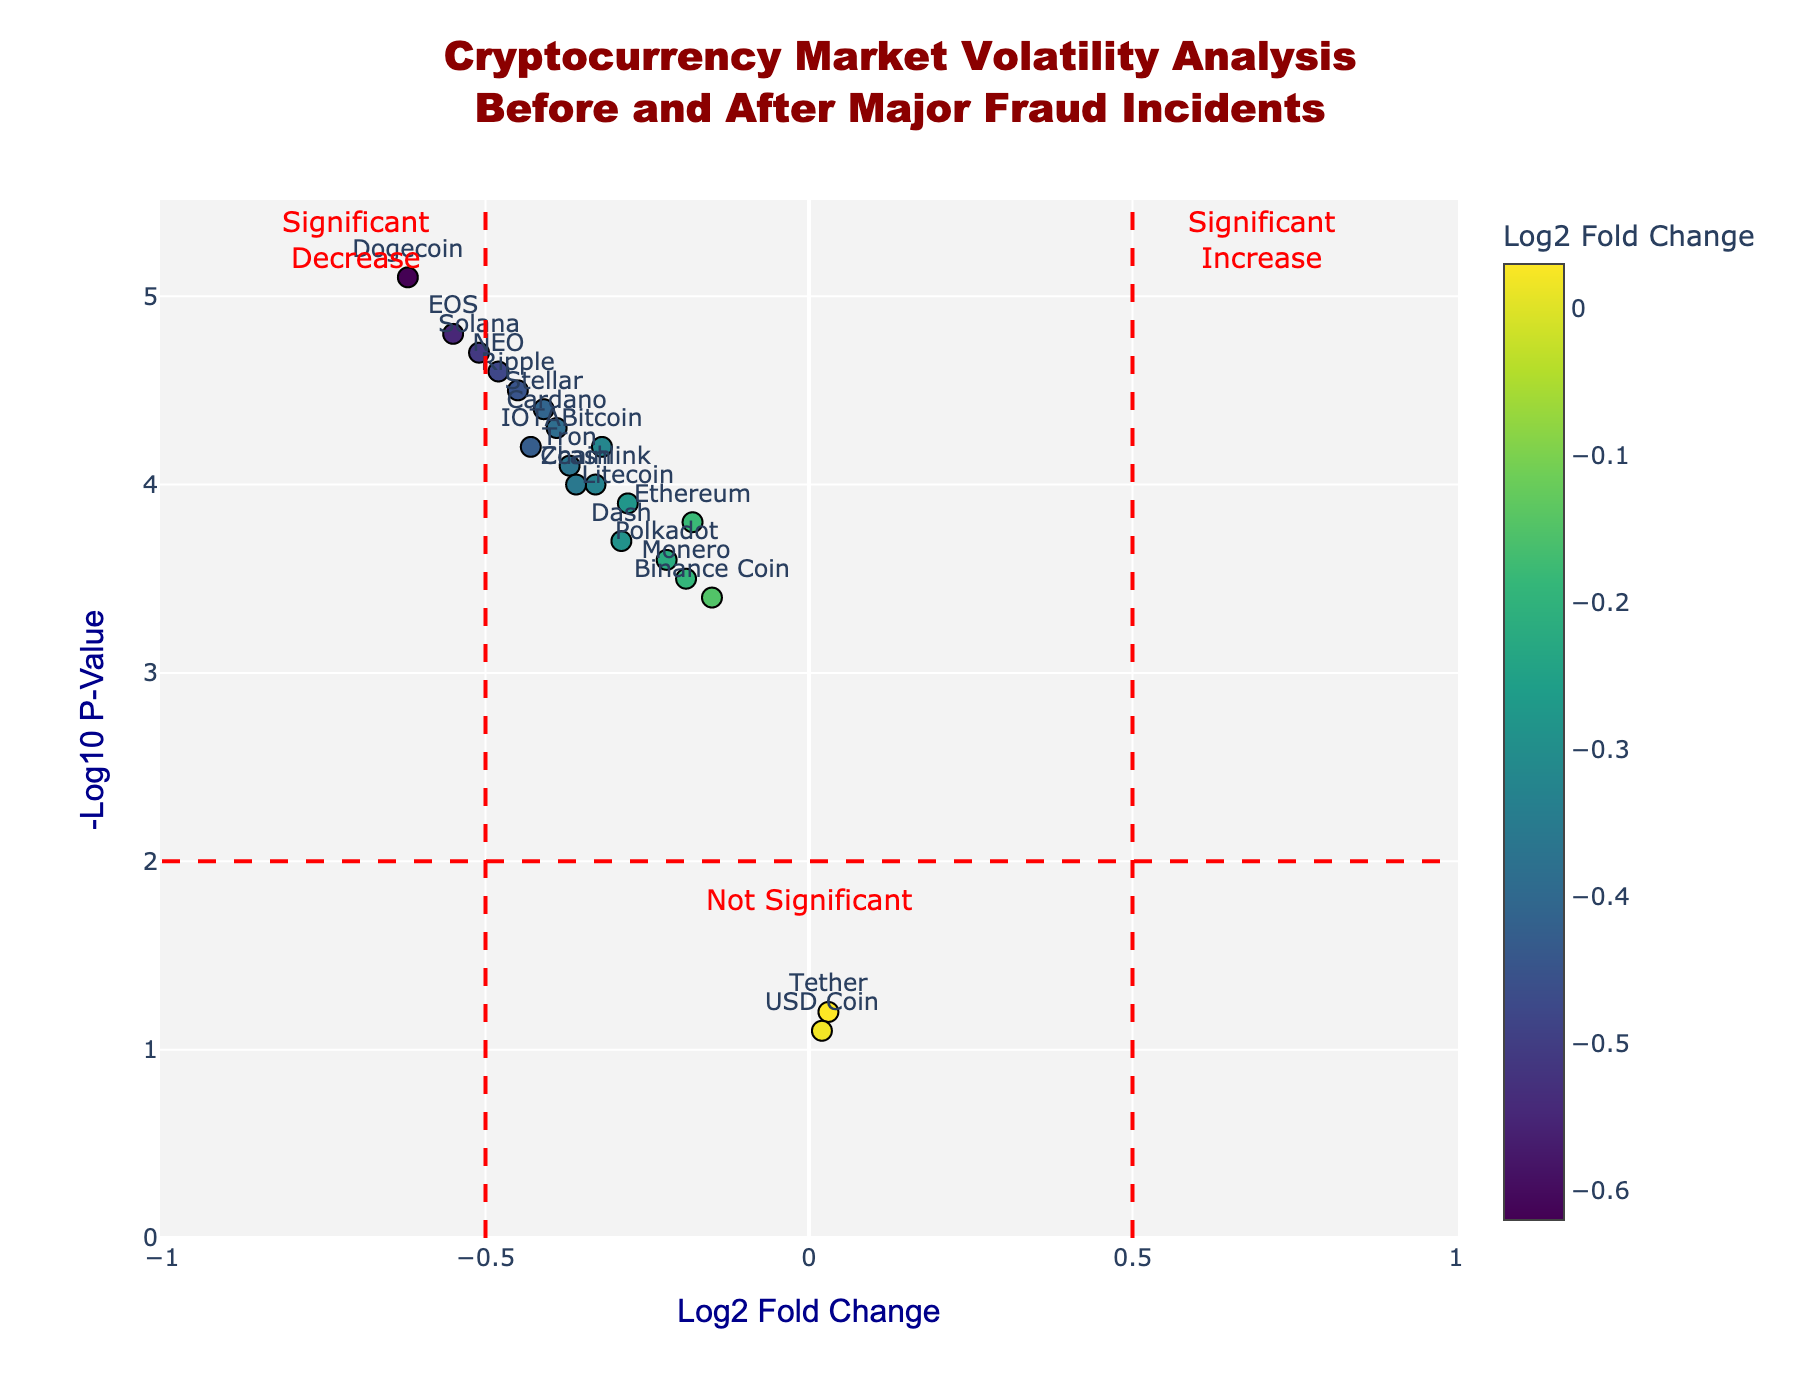What's the title of the figure? The title of the figure is prominently displayed at the top in bold font.
Answer: Cryptocurrency Market Volatility Analysis Before and After Major Fraud Incidents What do the x-axis and y-axis represent? The x-axis represents the Log2 Fold Change, and the y-axis represents the Negative Log10 P-Value, as indicated by the axis titles.
Answer: Log2 Fold Change, Negative Log10 P-Value How many data points are shown in the plot? Each cryptocurrency is represented as a data point in the scatter plot. By counting the unique cryptocurrency names displayed, we see there are 20 data points.
Answer: 20 Which cryptocurrency shows the highest increase in market volatility? The cryptocurrency located furthest to the right on the x-axis has the highest positive Log2 Fold Change, which corresponds to an increase in market volatility. The hover text or label next to the farthest right point indicates the cryptocurrency.
Answer: Tether Which cryptocurrency shows the most significant decrease in market volatility? The cryptocurrency located furthest to the left on the x-axis has the highest negative Log2 Fold Change, and the highest on the y-axis indicates a significant P-Value. The farthest left point reads Dogecoin.
Answer: Dogecoin What is the range of values on the y-axis for Negative Log10 P-Value? By looking at the y-axis, we can see the minimum and maximum values marked on the scale. The range is from 0 to 5.5.
Answer: 0 to 5.5 Are there any cryptocurrencies that are not significantly affected (below threshold)? Data points below the horizontal red dashed line at y = 2 indicate non-significance. Hover over these points or check their labels to identify the cryptocurrencies.
Answer: Tether, USD Coin Which data point corresponds to the largest negative Log2 Fold Change and what is its value and associated cryptocurrency? By hovering over the leftmost data point or checking its label, we recognize the cryptocurrency and its value. Dogecoin has the largest negative Log2 Fold Change of -0.62.
Answer: Dogecoin, -0.62 What color pattern is used to indicate the Log2 Fold Change in this plot? The color of each data point varies along a color scale from the plot legend indicating their Log2 Fold Change. The color scale used is 'Viridis.'
Answer: Viridis scale 